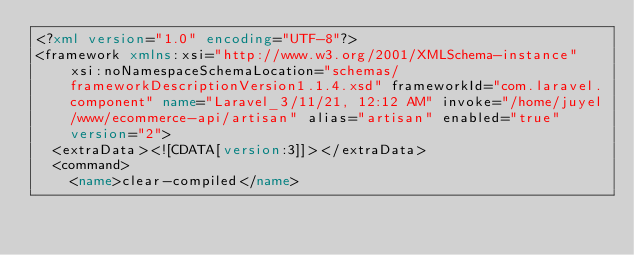<code> <loc_0><loc_0><loc_500><loc_500><_XML_><?xml version="1.0" encoding="UTF-8"?>
<framework xmlns:xsi="http://www.w3.org/2001/XMLSchema-instance" xsi:noNamespaceSchemaLocation="schemas/frameworkDescriptionVersion1.1.4.xsd" frameworkId="com.laravel.component" name="Laravel_3/11/21, 12:12 AM" invoke="/home/juyel/www/ecommerce-api/artisan" alias="artisan" enabled="true" version="2">
  <extraData><![CDATA[version:3]]></extraData>
  <command>
    <name>clear-compiled</name></code> 